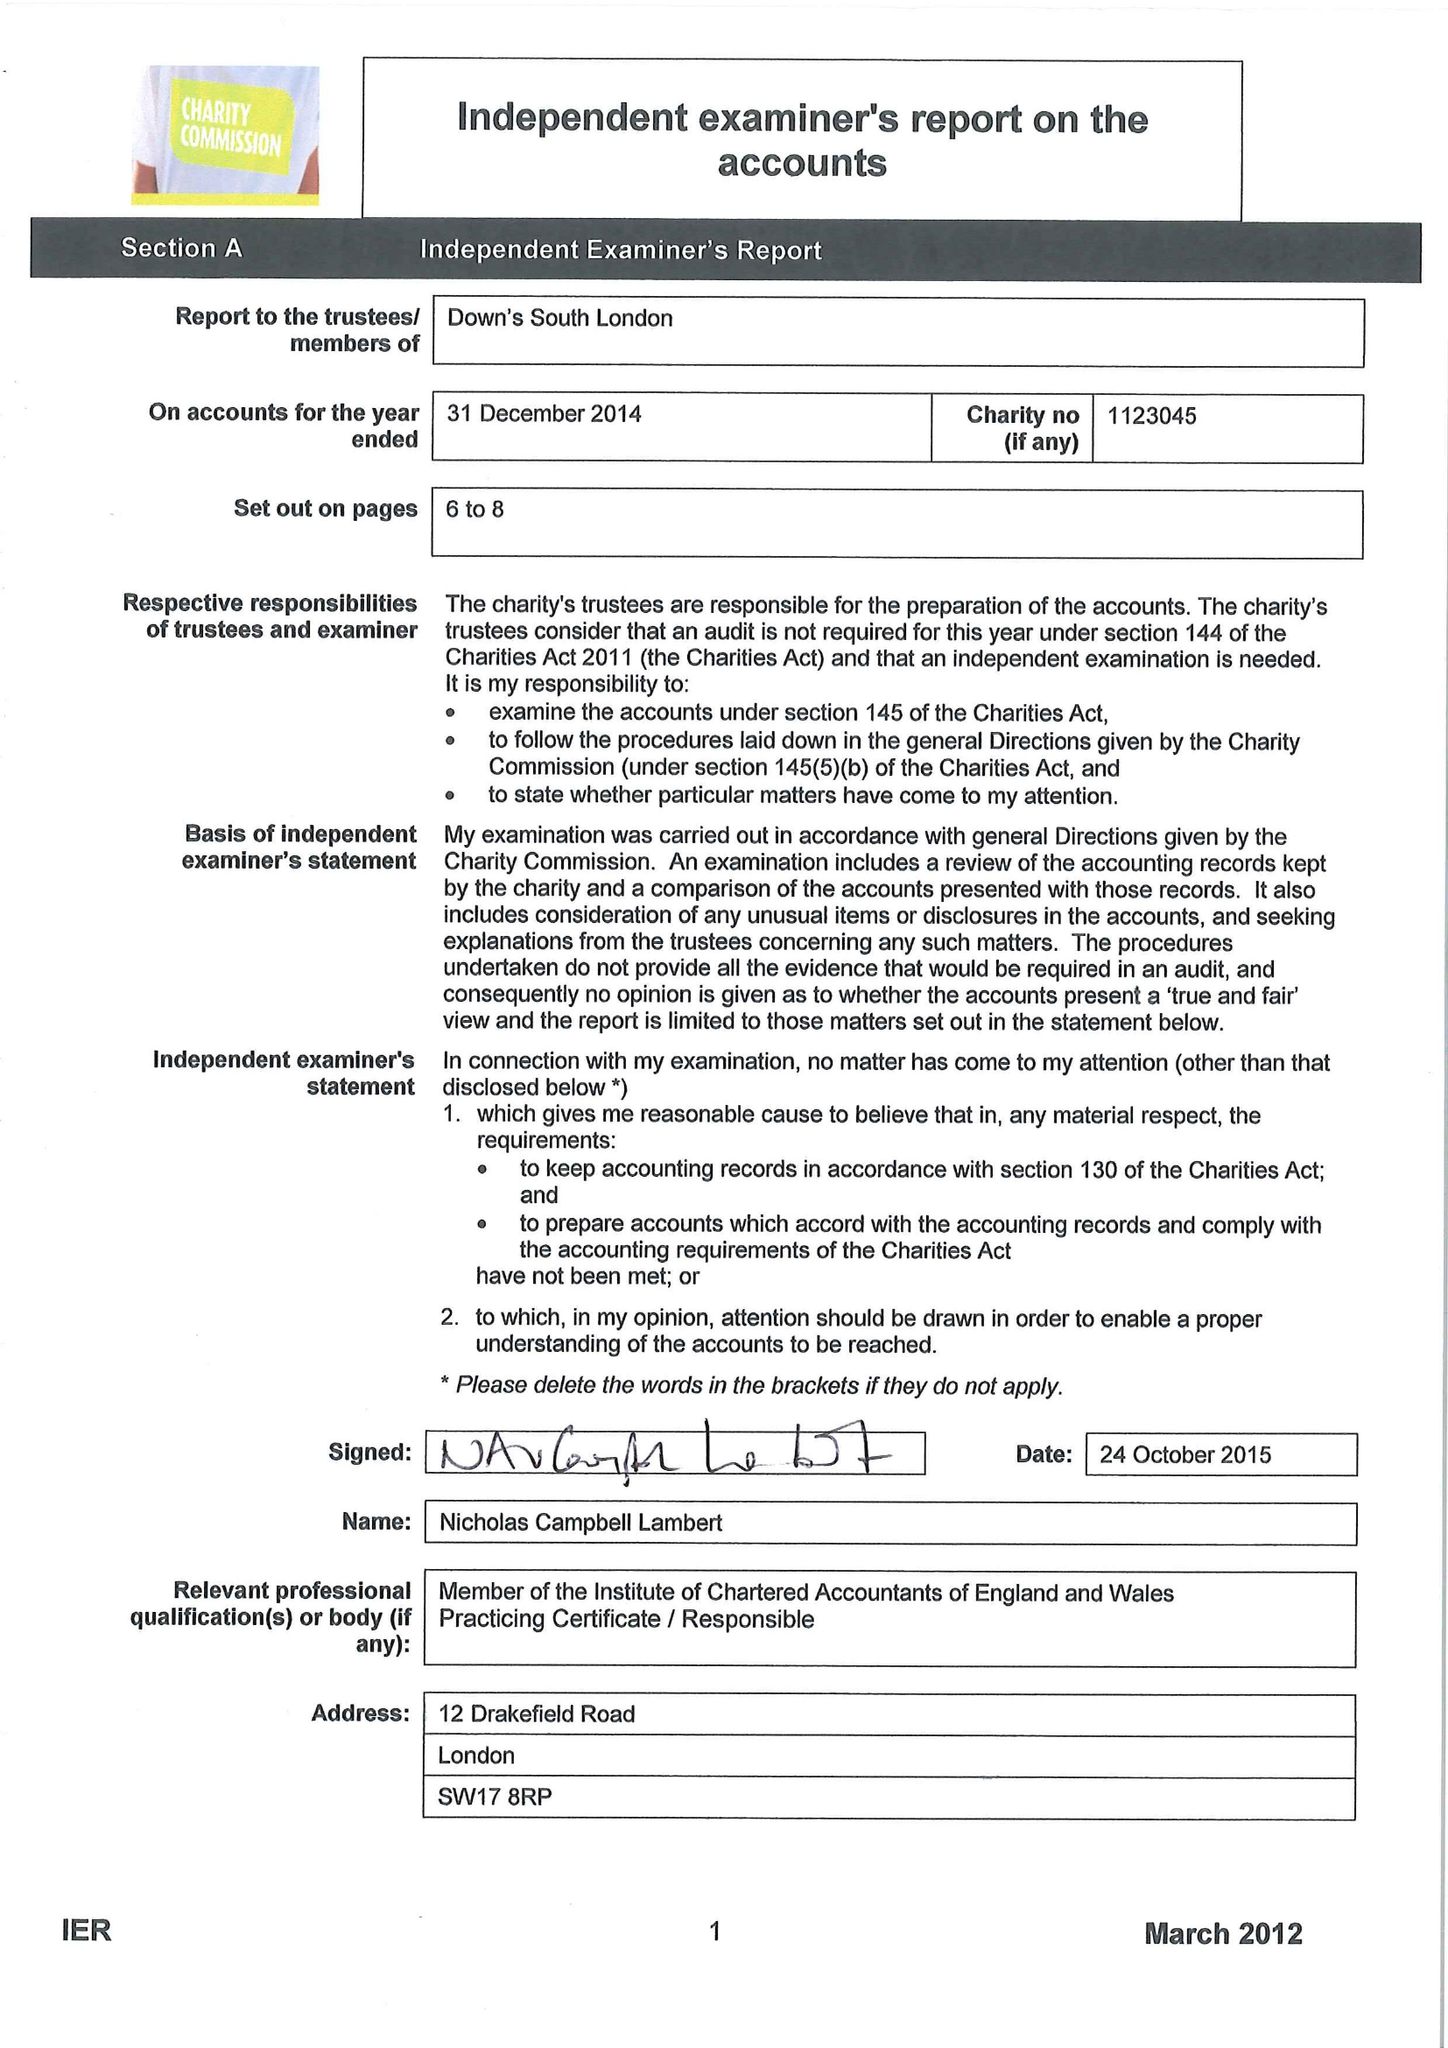What is the value for the address__postcode?
Answer the question using a single word or phrase. SE15 5AW 